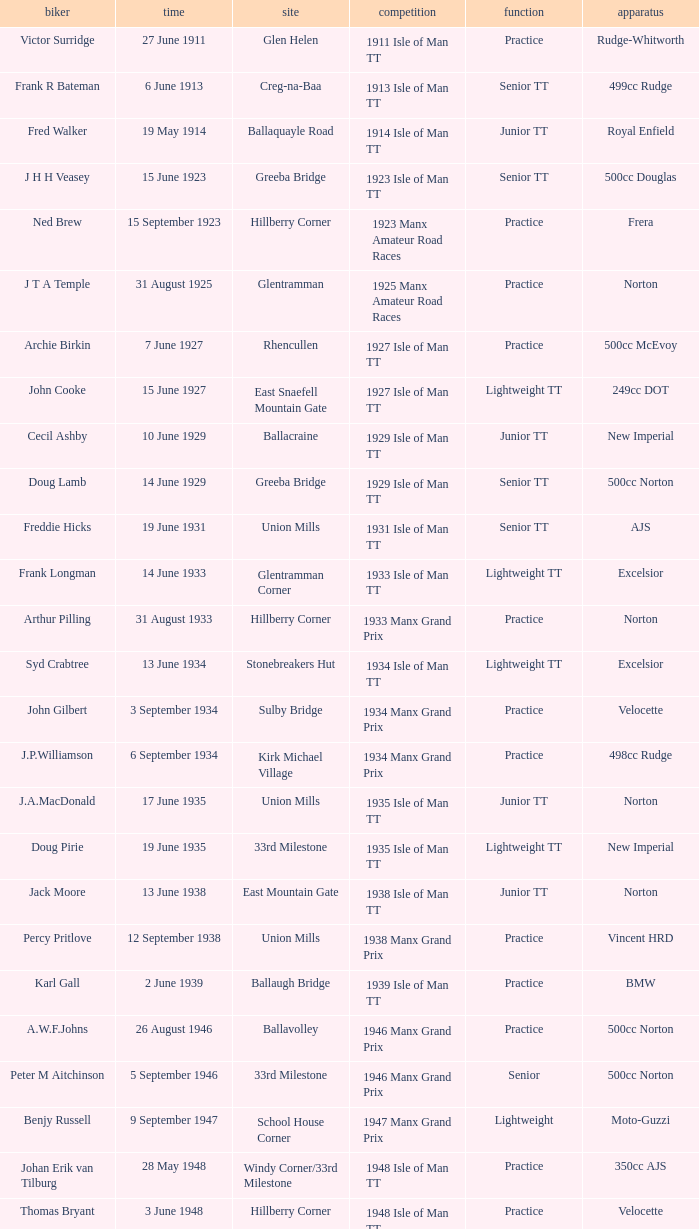What machine did Keith T. Gawler ride? 499cc Norton. 